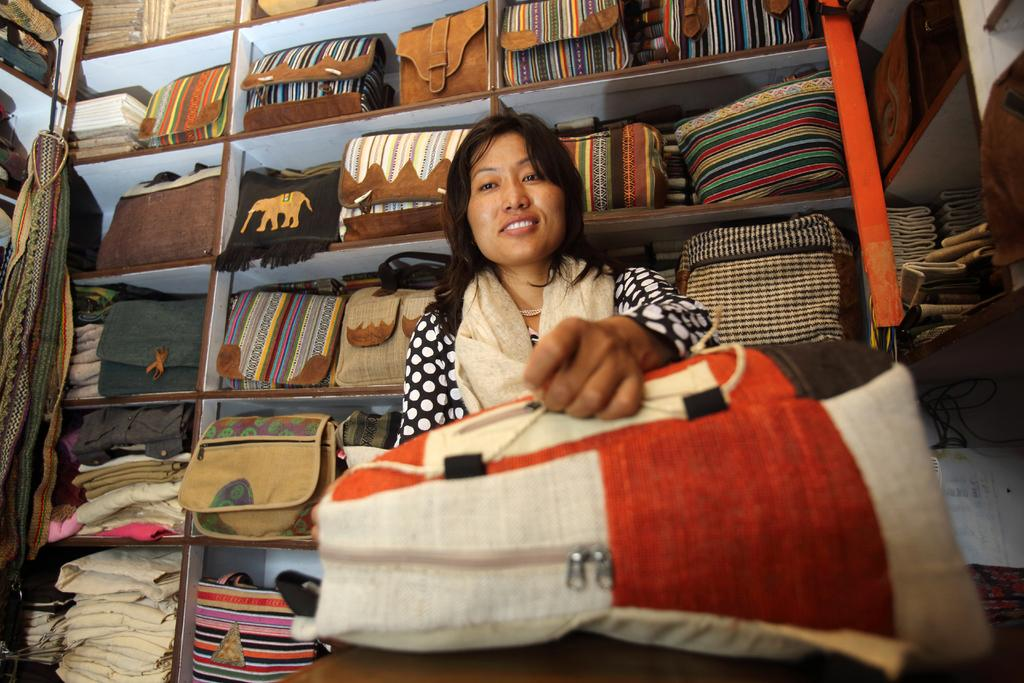Who is in the image? There is a woman in the image. What is the woman doing? The woman is smiling. What is the woman holding in the image? The woman is holding a bag. What can be seen in the background of the image? There are many bags, cloth items, and wooden racks with objects placed on them in the background. What type of rhythm can be heard in the image? There is no audible rhythm in the image, as it is a still photograph. 